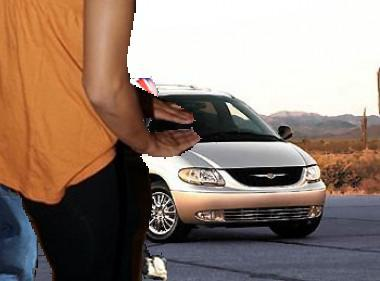What make and model is the car in the image? The car in the image is a Chrysler Concorde. You can recognize it by its distinctive front grille and headlights typical of the early 2000s models. 